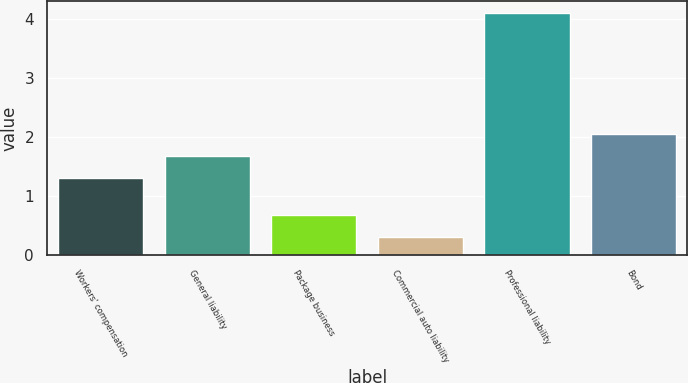<chart> <loc_0><loc_0><loc_500><loc_500><bar_chart><fcel>Workers' compensation<fcel>General liability<fcel>Package business<fcel>Commercial auto liability<fcel>Professional liability<fcel>Bond<nl><fcel>1.3<fcel>1.68<fcel>0.68<fcel>0.3<fcel>4.1<fcel>2.06<nl></chart> 